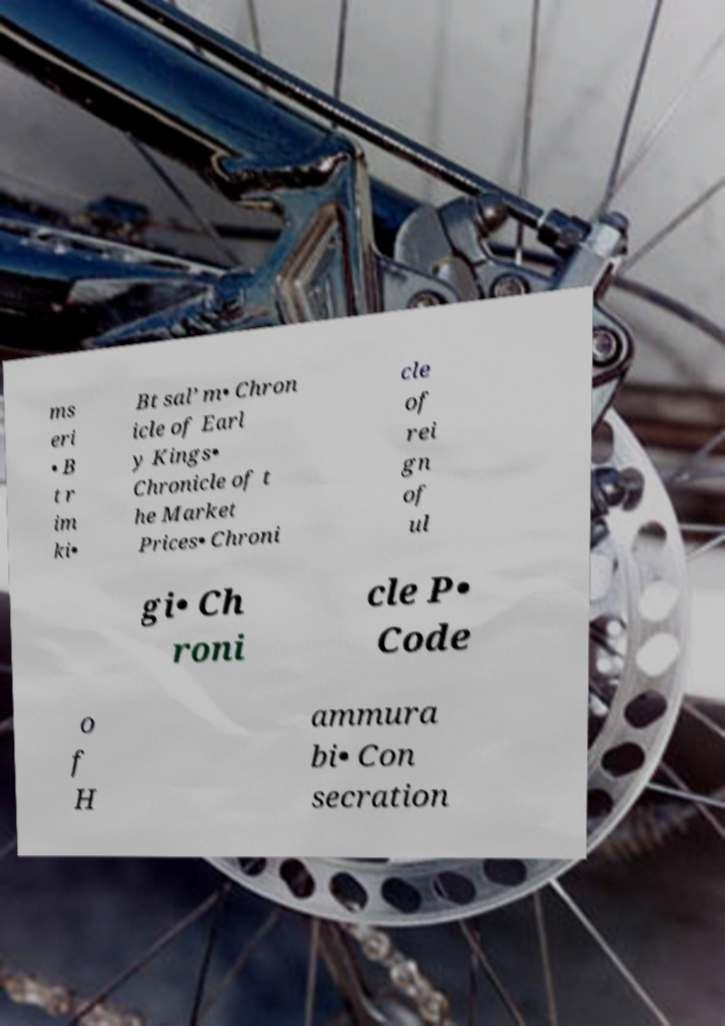For documentation purposes, I need the text within this image transcribed. Could you provide that? ms eri • B t r im ki• Bt sal’ m• Chron icle of Earl y Kings• Chronicle of t he Market Prices• Chroni cle of rei gn of ul gi• Ch roni cle P• Code o f H ammura bi• Con secration 